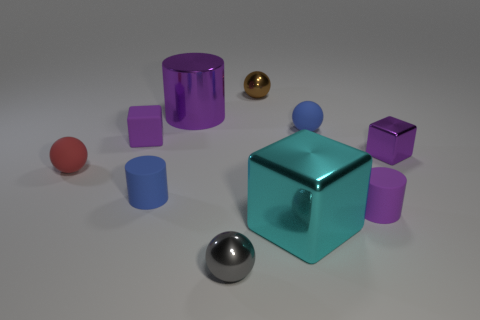Subtract all big cyan blocks. How many blocks are left? 2 Subtract all gray spheres. How many spheres are left? 3 Subtract all cubes. How many objects are left? 7 Subtract 1 cubes. How many cubes are left? 2 Subtract all small yellow cylinders. Subtract all big blocks. How many objects are left? 9 Add 1 red matte spheres. How many red matte spheres are left? 2 Add 3 blue cubes. How many blue cubes exist? 3 Subtract 0 green balls. How many objects are left? 10 Subtract all blue blocks. Subtract all brown cylinders. How many blocks are left? 3 Subtract all purple spheres. How many cyan cubes are left? 1 